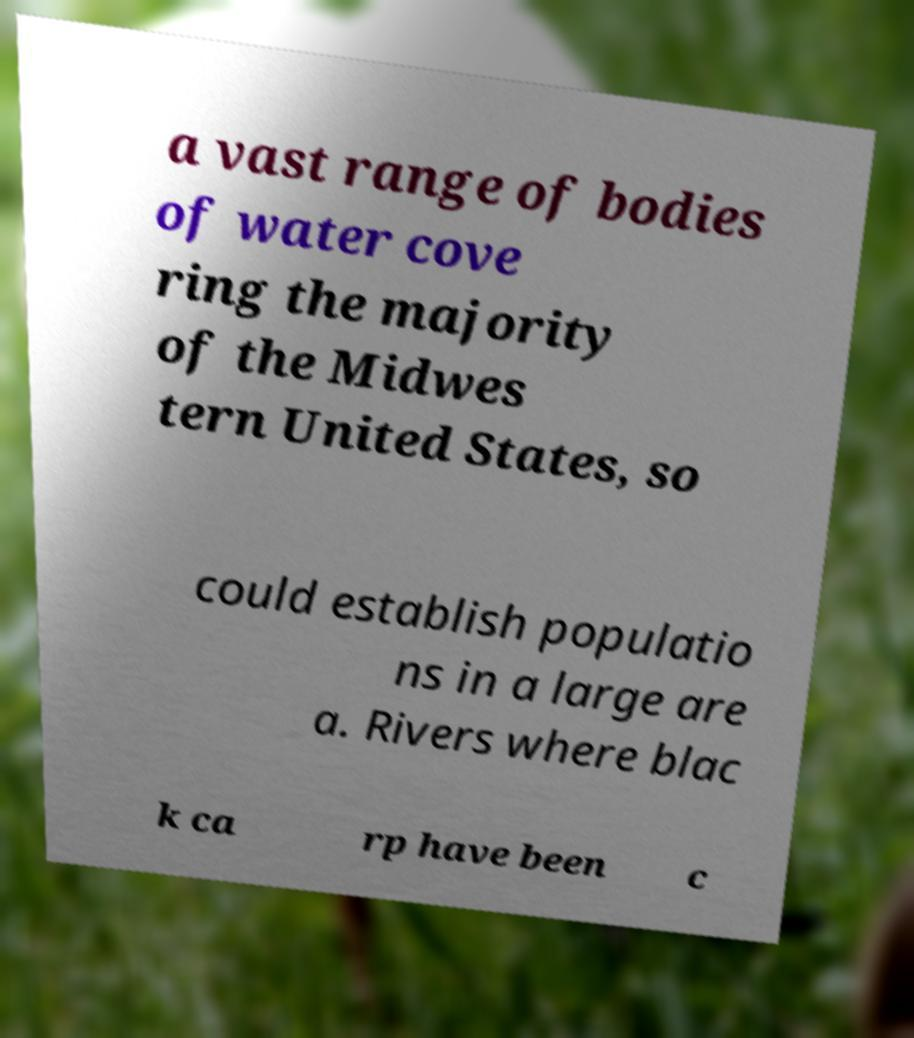Please read and relay the text visible in this image. What does it say? a vast range of bodies of water cove ring the majority of the Midwes tern United States, so could establish populatio ns in a large are a. Rivers where blac k ca rp have been c 